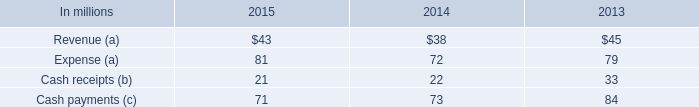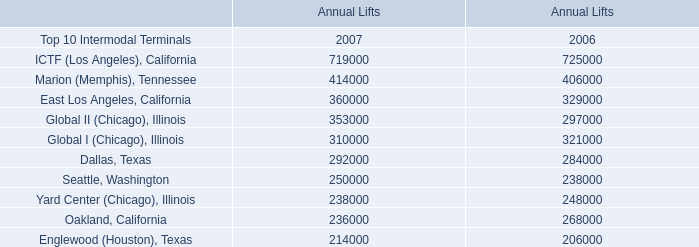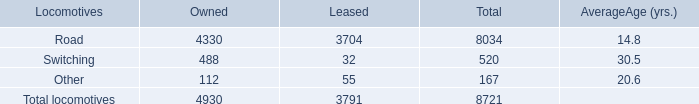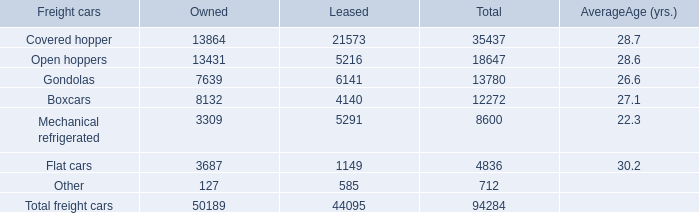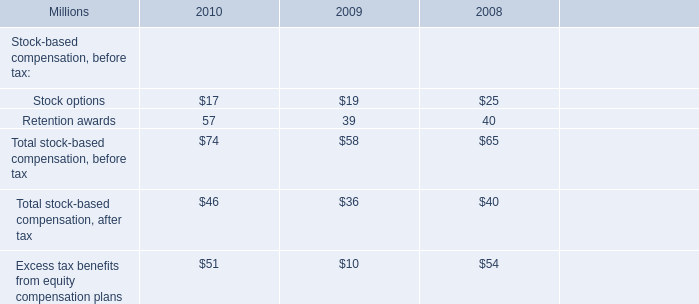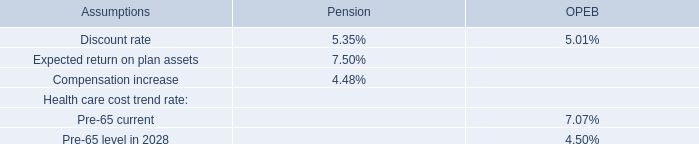As As the chart 1 shows,in 2007, what is the Annual Lifts for the Top 10 Intermodal Terminals Dallas, Texas? 
Answer: 292000. 